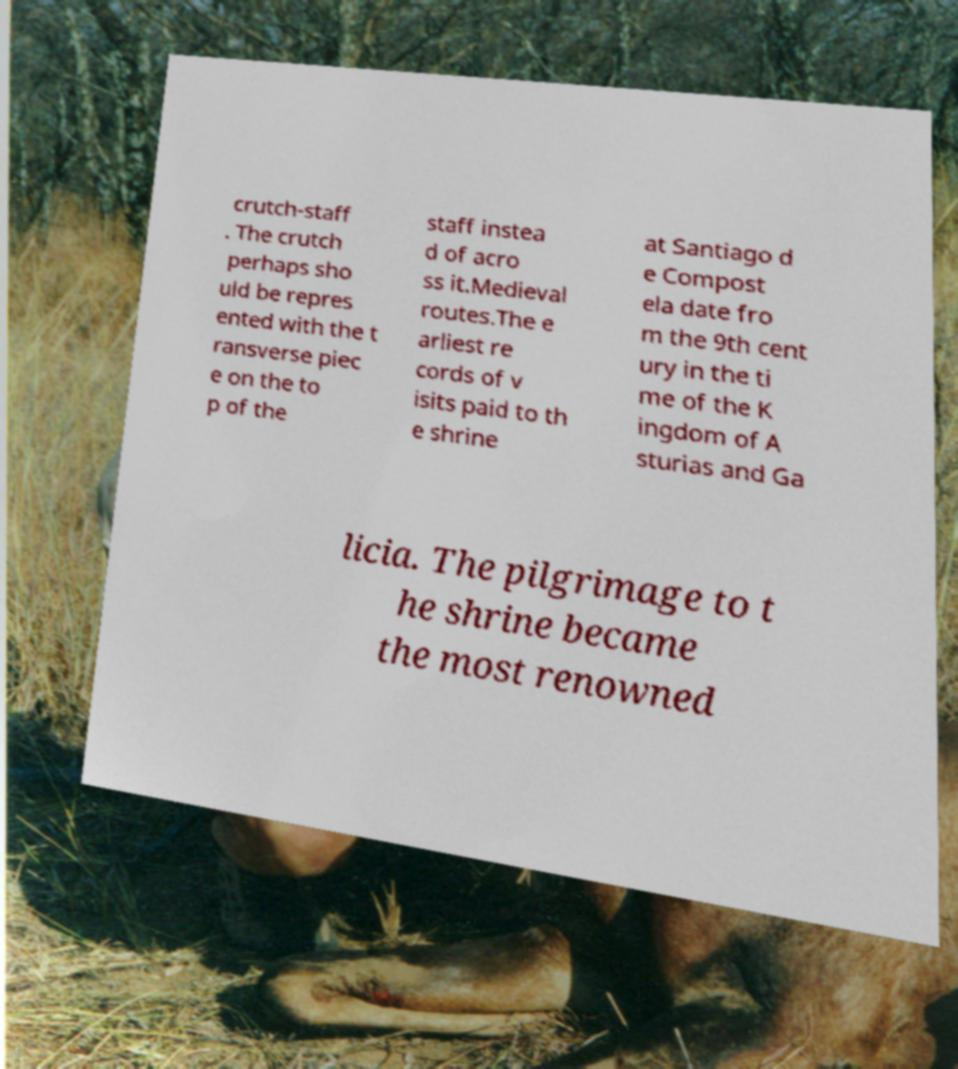Please identify and transcribe the text found in this image. crutch-staff . The crutch perhaps sho uld be repres ented with the t ransverse piec e on the to p of the staff instea d of acro ss it.Medieval routes.The e arliest re cords of v isits paid to th e shrine at Santiago d e Compost ela date fro m the 9th cent ury in the ti me of the K ingdom of A sturias and Ga licia. The pilgrimage to t he shrine became the most renowned 